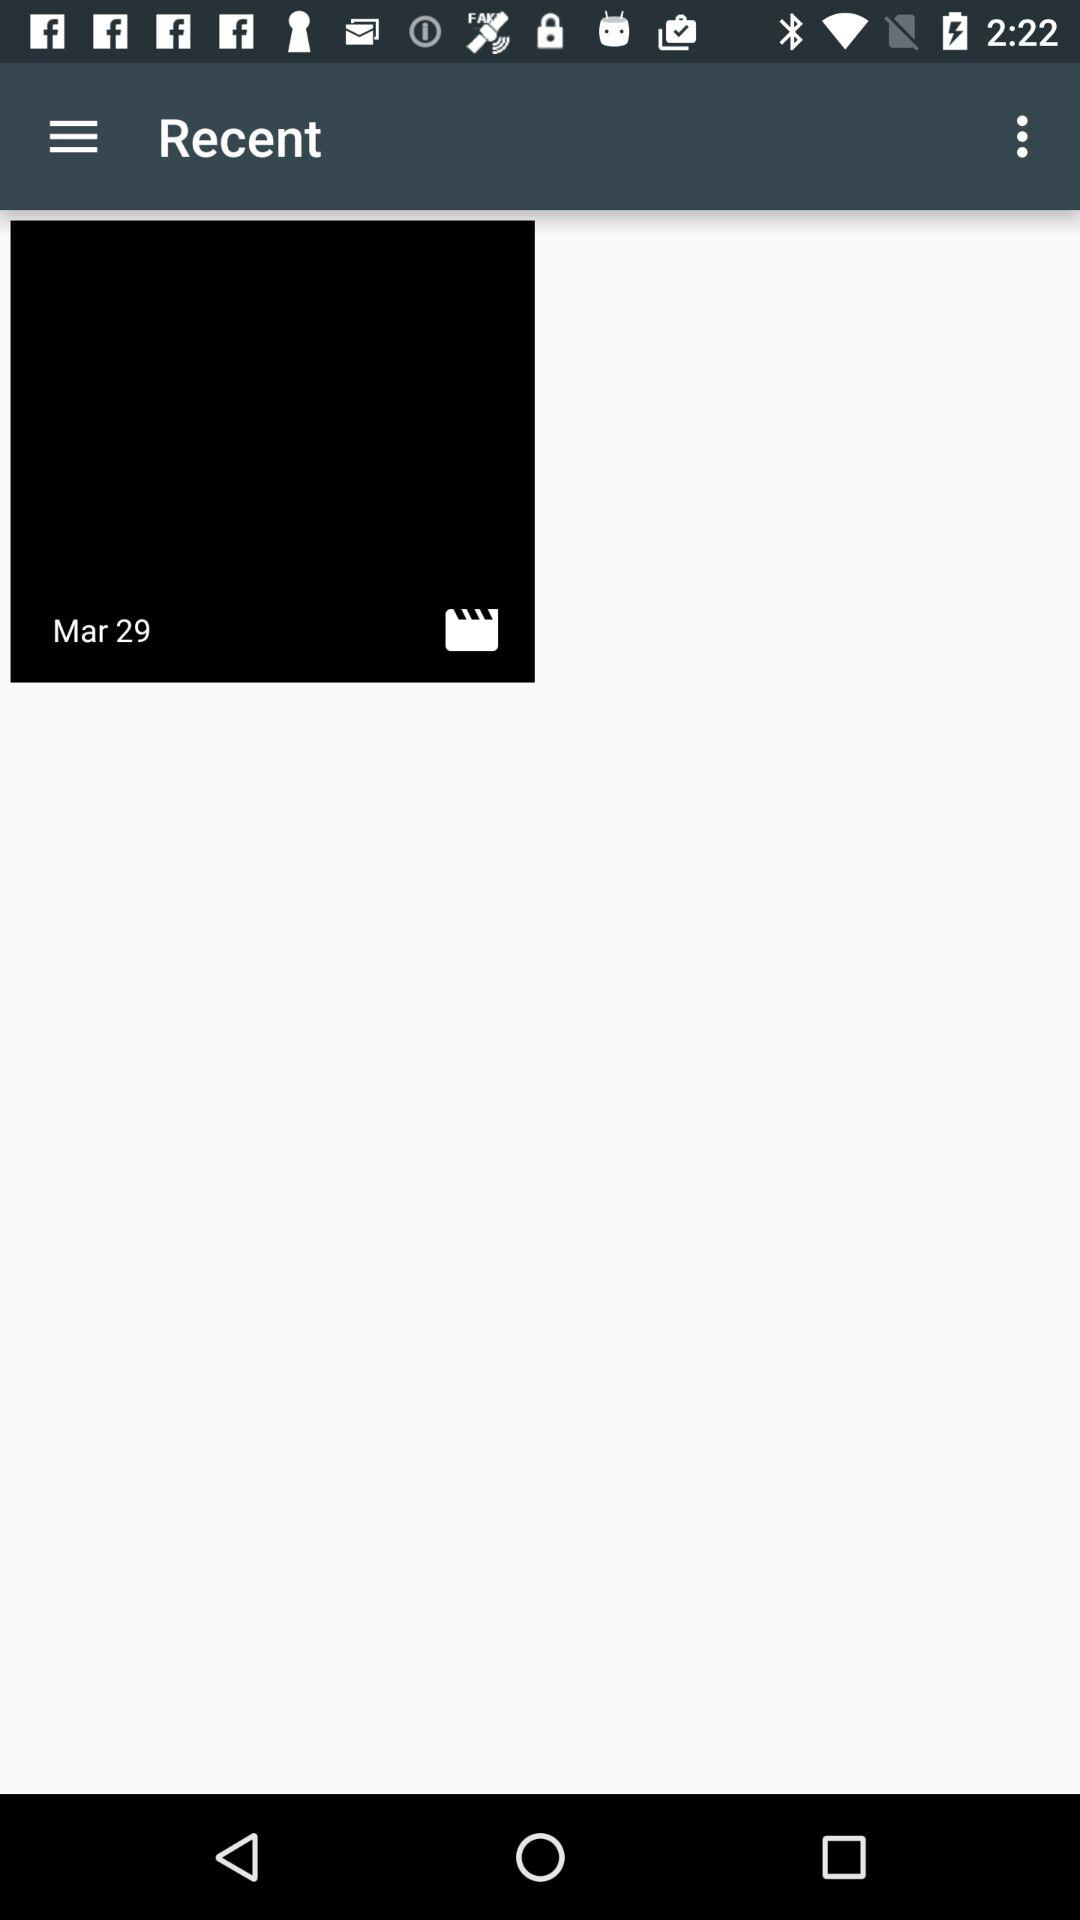Who posted the videos?
When the provided information is insufficient, respond with <no answer>. <no answer> 